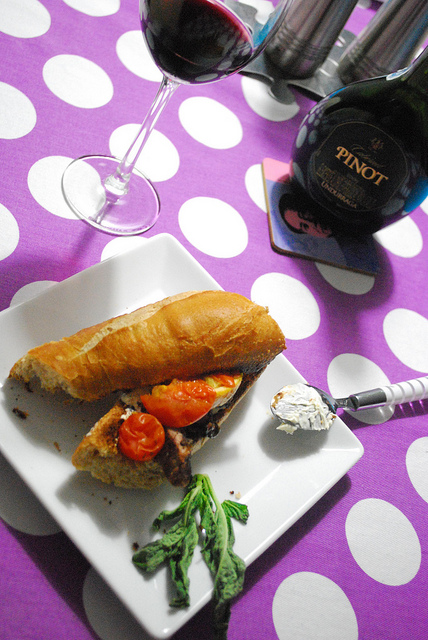Identify and read out the text in this image. PINOT 